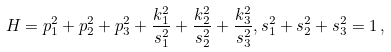<formula> <loc_0><loc_0><loc_500><loc_500>H = p _ { 1 } ^ { 2 } + p _ { 2 } ^ { 2 } + p _ { 3 } ^ { 2 } + \frac { k _ { 1 } ^ { 2 } } { s _ { 1 } ^ { 2 } } + \frac { k _ { 2 } ^ { 2 } } { s _ { 2 } ^ { 2 } } + \frac { k _ { 3 } ^ { 2 } } { s _ { 3 } ^ { 2 } } , s _ { 1 } ^ { 2 } + s _ { 2 } ^ { 2 } + s _ { 3 } ^ { 2 } = 1 \, ,</formula> 